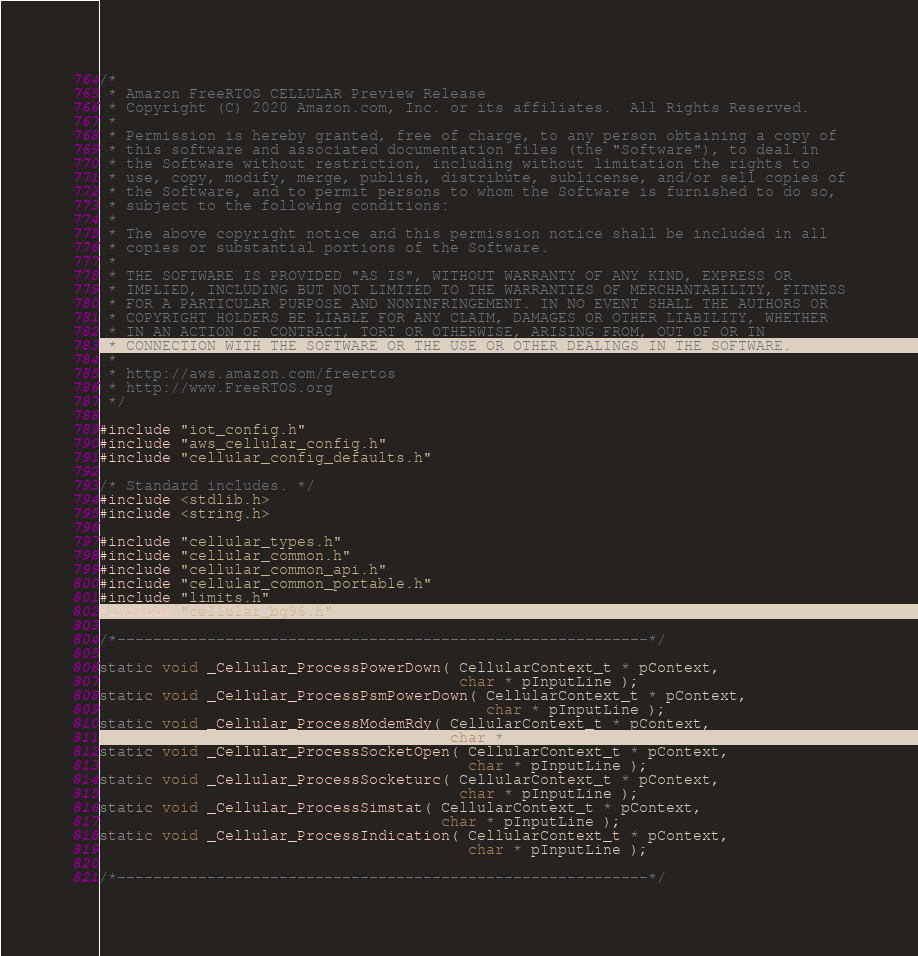<code> <loc_0><loc_0><loc_500><loc_500><_C_>/*
 * Amazon FreeRTOS CELLULAR Preview Release
 * Copyright (C) 2020 Amazon.com, Inc. or its affiliates.  All Rights Reserved.
 *
 * Permission is hereby granted, free of charge, to any person obtaining a copy of
 * this software and associated documentation files (the "Software"), to deal in
 * the Software without restriction, including without limitation the rights to
 * use, copy, modify, merge, publish, distribute, sublicense, and/or sell copies of
 * the Software, and to permit persons to whom the Software is furnished to do so,
 * subject to the following conditions:
 *
 * The above copyright notice and this permission notice shall be included in all
 * copies or substantial portions of the Software.
 *
 * THE SOFTWARE IS PROVIDED "AS IS", WITHOUT WARRANTY OF ANY KIND, EXPRESS OR
 * IMPLIED, INCLUDING BUT NOT LIMITED TO THE WARRANTIES OF MERCHANTABILITY, FITNESS
 * FOR A PARTICULAR PURPOSE AND NONINFRINGEMENT. IN NO EVENT SHALL THE AUTHORS OR
 * COPYRIGHT HOLDERS BE LIABLE FOR ANY CLAIM, DAMAGES OR OTHER LIABILITY, WHETHER
 * IN AN ACTION OF CONTRACT, TORT OR OTHERWISE, ARISING FROM, OUT OF OR IN
 * CONNECTION WITH THE SOFTWARE OR THE USE OR OTHER DEALINGS IN THE SOFTWARE.
 *
 * http://aws.amazon.com/freertos
 * http://www.FreeRTOS.org
 */

#include "iot_config.h"
#include "aws_cellular_config.h"
#include "cellular_config_defaults.h"

/* Standard includes. */
#include <stdlib.h>
#include <string.h>

#include "cellular_types.h"
#include "cellular_common.h"
#include "cellular_common_api.h"
#include "cellular_common_portable.h"
#include "limits.h"
#include "cellular_bg96.h"

/*-----------------------------------------------------------*/

static void _Cellular_ProcessPowerDown( CellularContext_t * pContext,
                                        char * pInputLine );
static void _Cellular_ProcessPsmPowerDown( CellularContext_t * pContext,
                                           char * pInputLine );
static void _Cellular_ProcessModemRdy( CellularContext_t * pContext,
                                       char * pInputLine );
static void _Cellular_ProcessSocketOpen( CellularContext_t * pContext,
                                         char * pInputLine );
static void _Cellular_ProcessSocketurc( CellularContext_t * pContext,
                                        char * pInputLine );
static void _Cellular_ProcessSimstat( CellularContext_t * pContext,
                                      char * pInputLine );
static void _Cellular_ProcessIndication( CellularContext_t * pContext,
                                         char * pInputLine );

/*-----------------------------------------------------------*/
</code> 